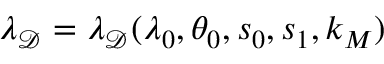<formula> <loc_0><loc_0><loc_500><loc_500>\lambda _ { \mathcal { D } } = \lambda _ { \mathcal { D } } ( \lambda _ { 0 } , \theta _ { 0 } , s _ { 0 } , s _ { 1 } , k _ { M } )</formula> 